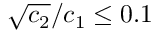Convert formula to latex. <formula><loc_0><loc_0><loc_500><loc_500>{ { \sqrt { c _ { 2 } } } / { c _ { 1 } } } \leq 0 . 1</formula> 